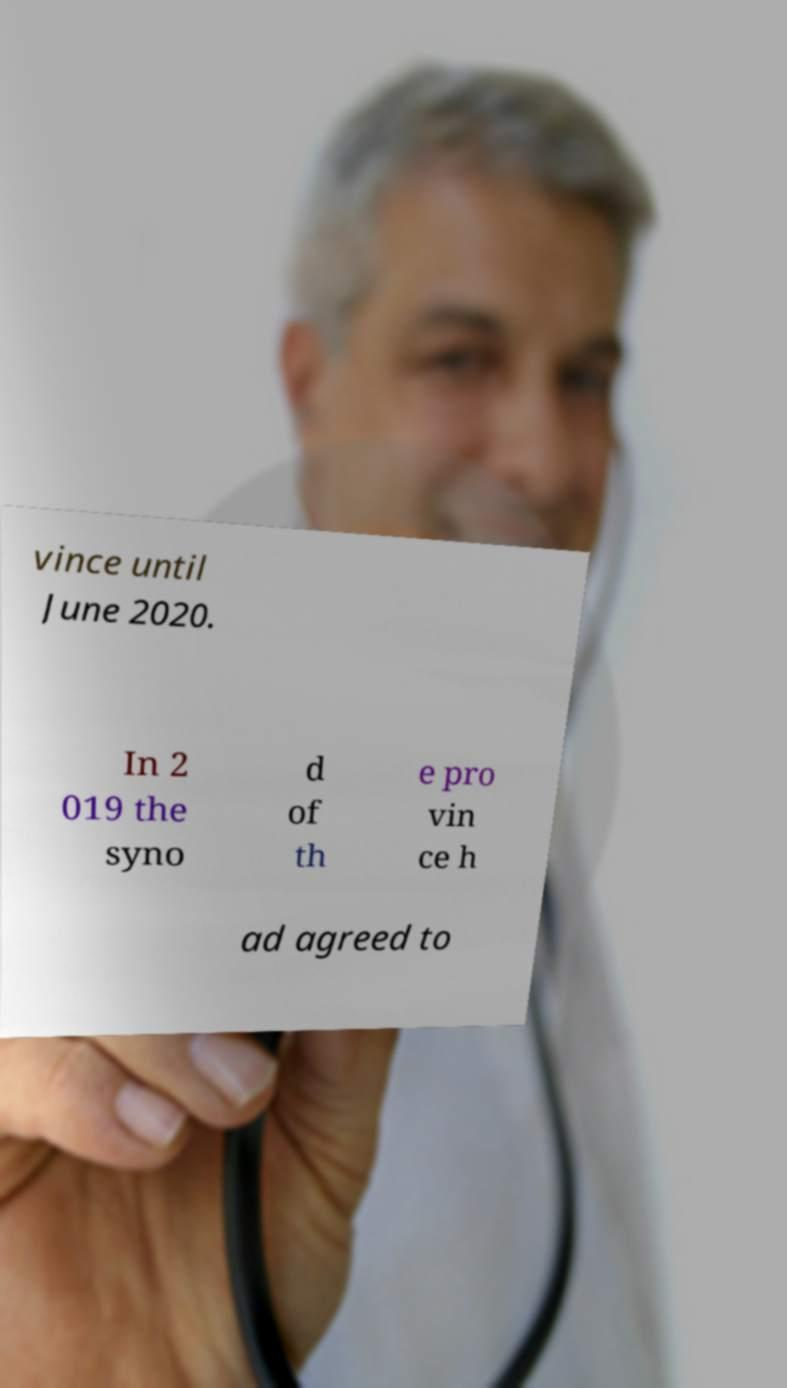Can you read and provide the text displayed in the image?This photo seems to have some interesting text. Can you extract and type it out for me? vince until June 2020. In 2 019 the syno d of th e pro vin ce h ad agreed to 